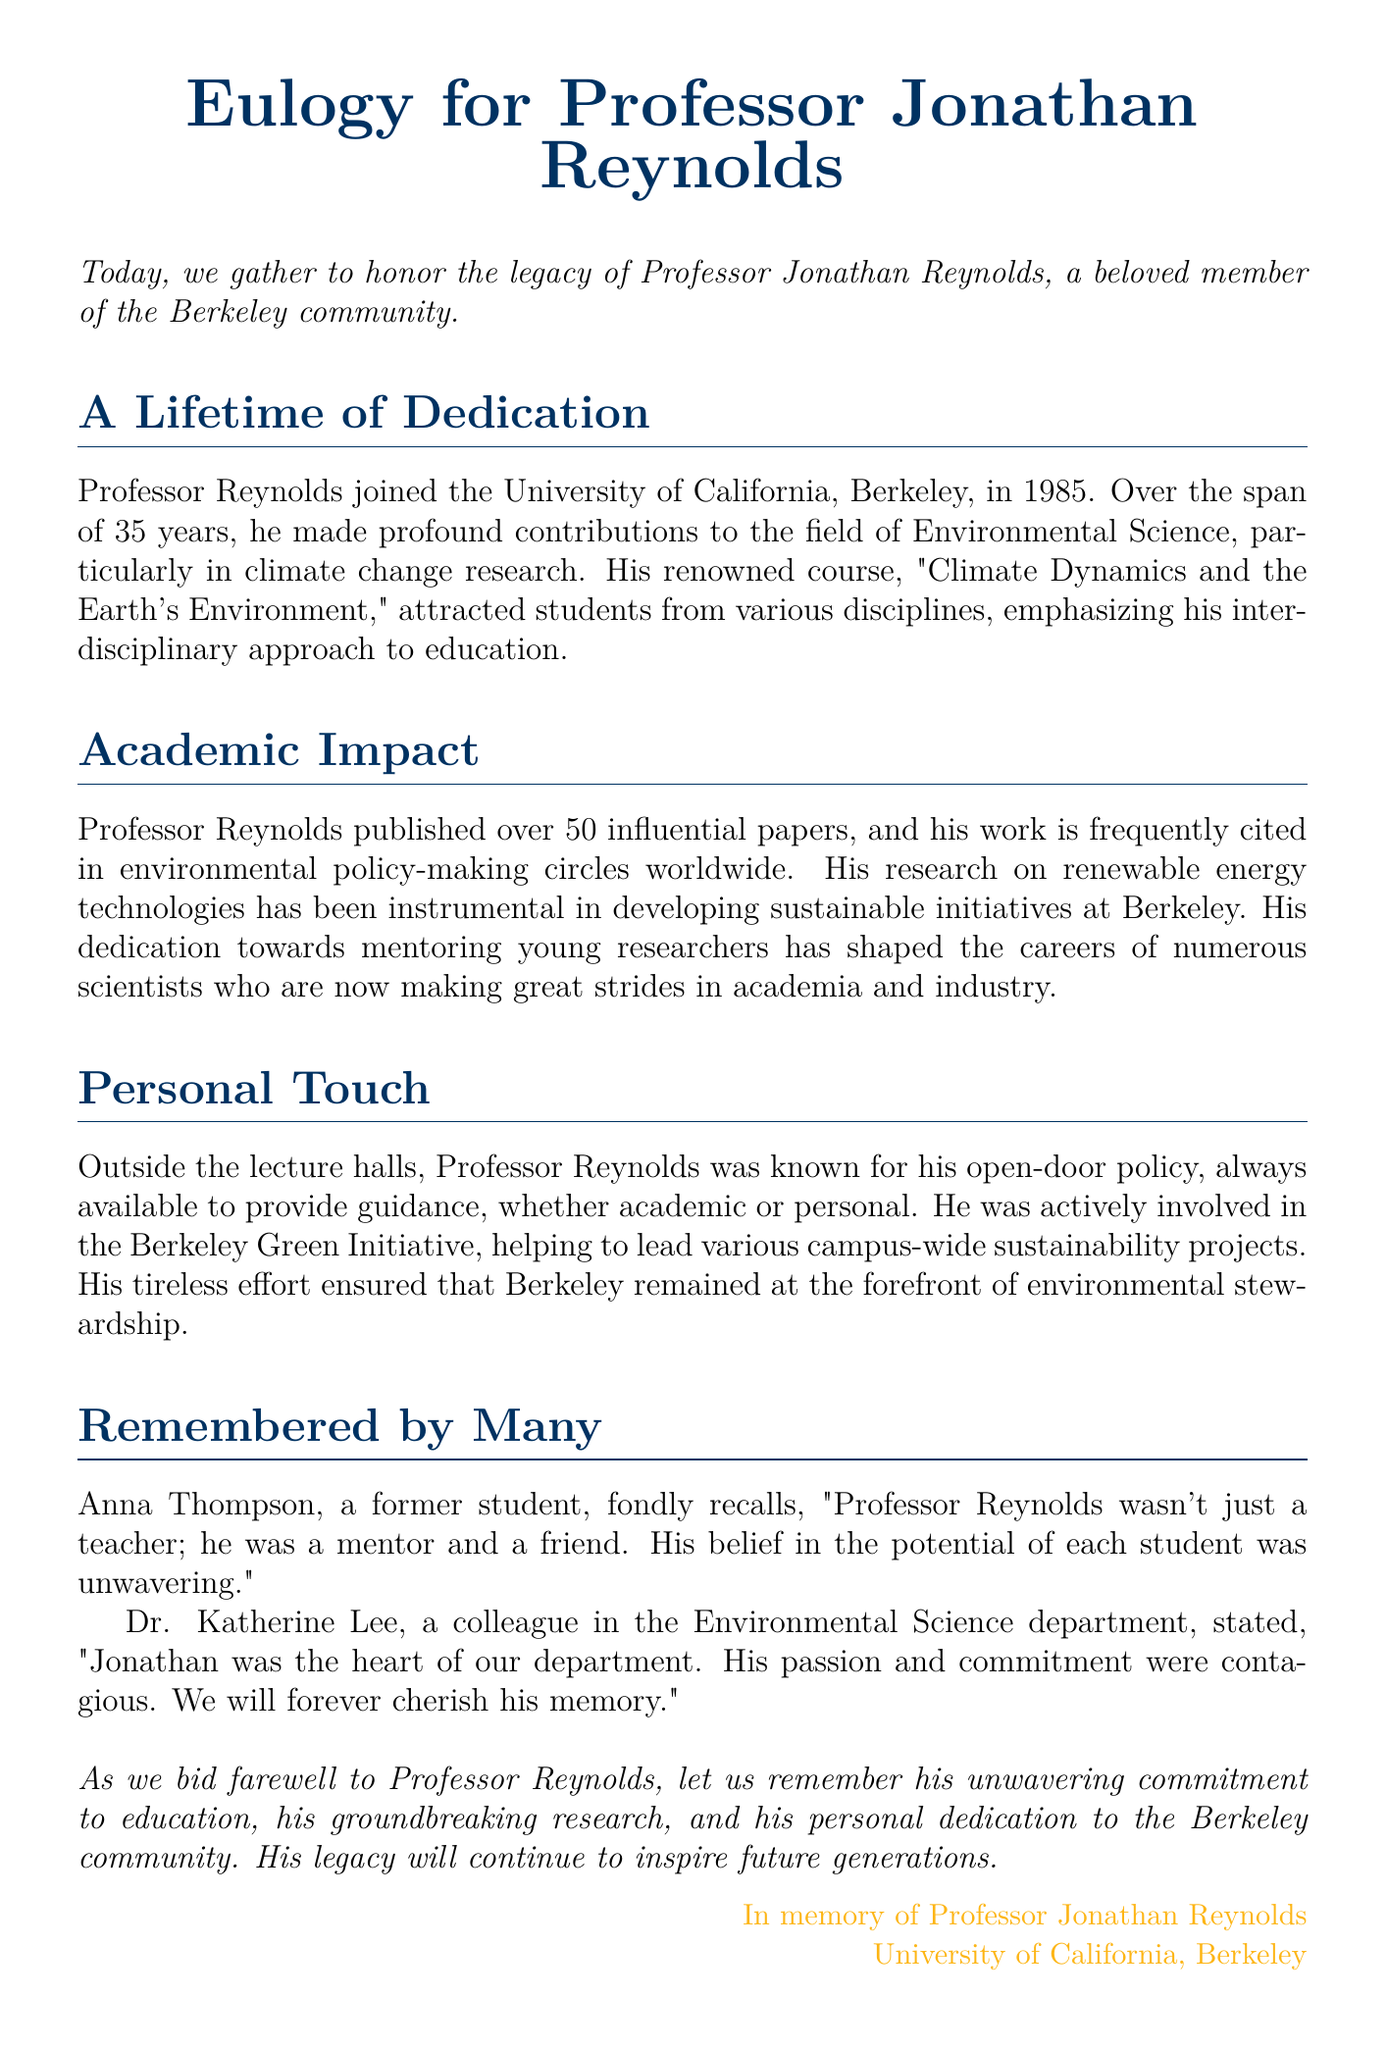What year did Professor Reynolds join Berkeley? The document states that Professor Reynolds joined the University of California, Berkeley in 1985.
Answer: 1985 How many influential papers did Professor Reynolds publish? It is mentioned that Professor Reynolds published over 50 influential papers.
Answer: Over 50 What was the name of Professor Reynolds's renowned course? The document refers to his renowned course as "Climate Dynamics and the Earth's Environment."
Answer: Climate Dynamics and the Earth's Environment Who is a former student that shared a memory of Professor Reynolds? The document cites Anna Thompson as a former student who fondly recalls Professor Reynolds.
Answer: Anna Thompson What initiative did Professor Reynolds actively participate in? The document mentions that he was involved in the Berkeley Green Initiative.
Answer: Berkeley Green Initiative What was emphasized in Professor Reynolds's approach to education? The document specifies that he emphasized an interdisciplinary approach to education.
Answer: Interdisciplinary approach Who described Professor Reynolds as "the heart of our department"? Dr. Katherine Lee is quoted as stating that Professor Reynolds was "the heart of our department."
Answer: Dr. Katherine Lee What is stated as part of Professor Reynolds's personal dedication? The document notes that he had an open-door policy and was always available to provide guidance.
Answer: Open-door policy 